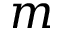Convert formula to latex. <formula><loc_0><loc_0><loc_500><loc_500>m</formula> 